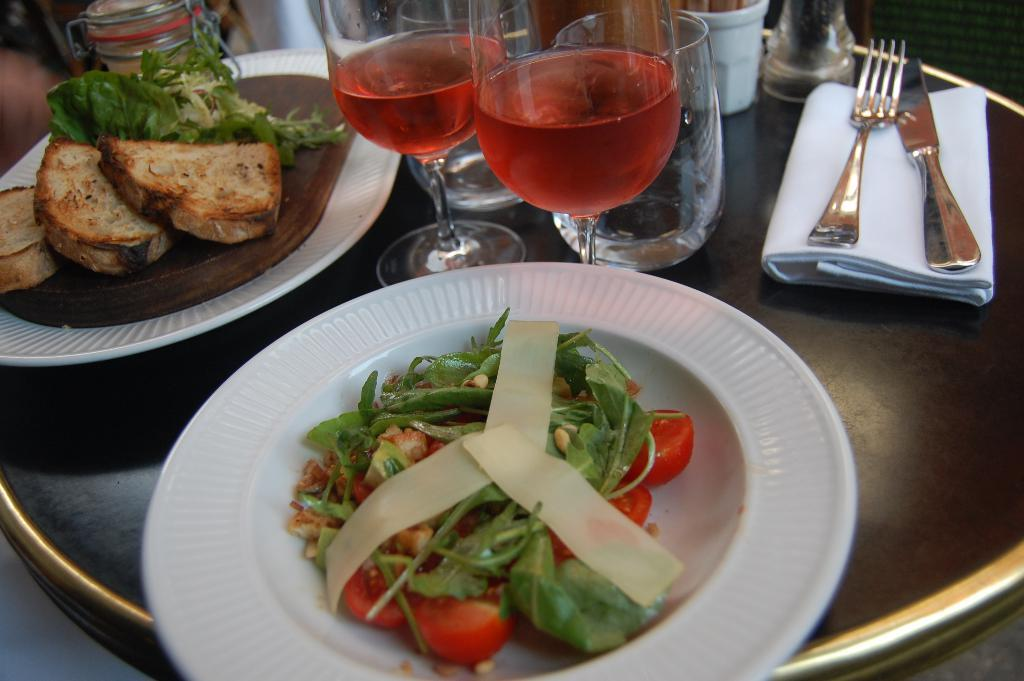What is present on the plates in the image? There is food in the plates. What can be seen on the table besides the plates? There are glasses, a fork, a knife, and a cloth on the table. How many boats are visible through the window in the image? There is no window or boats present in the image. What type of bottle is placed on the table in the image? There is no bottle present on the table in the image. 